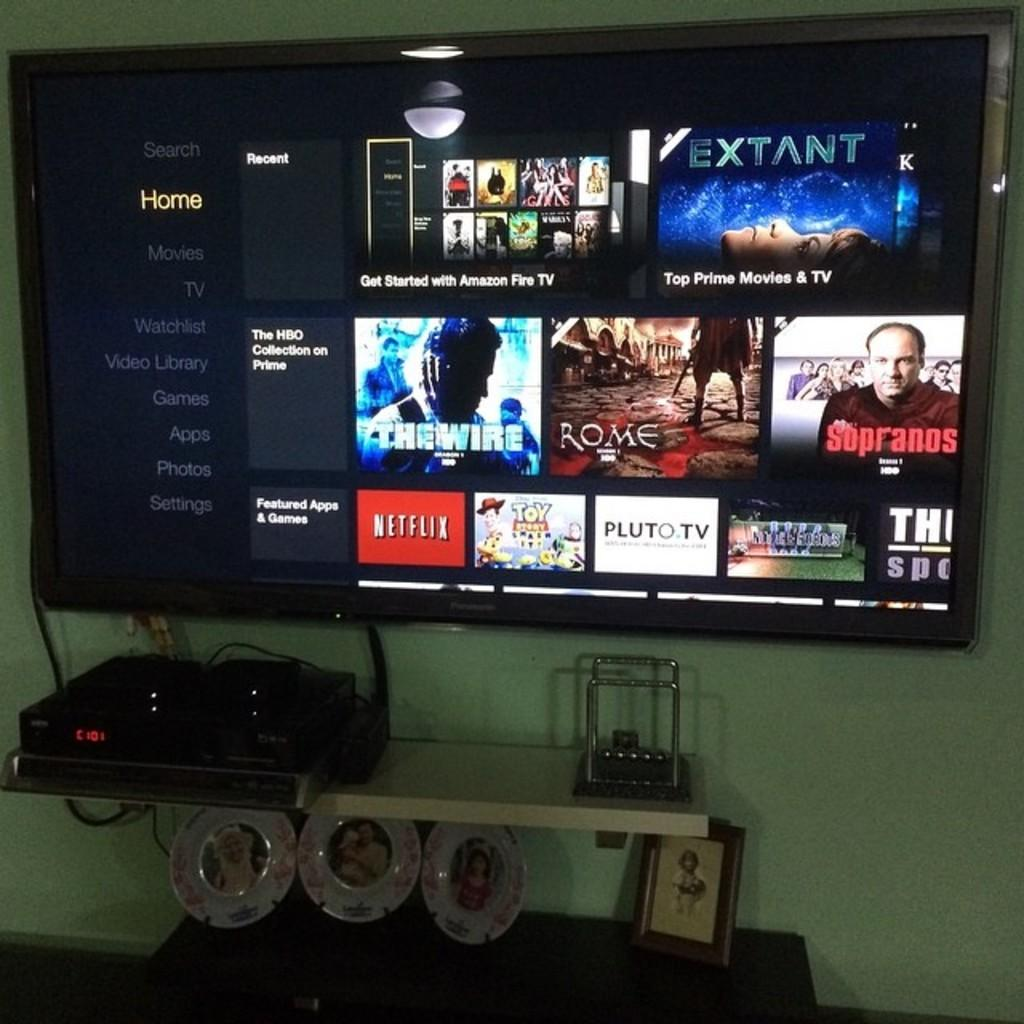<image>
Create a compact narrative representing the image presented. a Netflix logo that is on a screen with many other items 